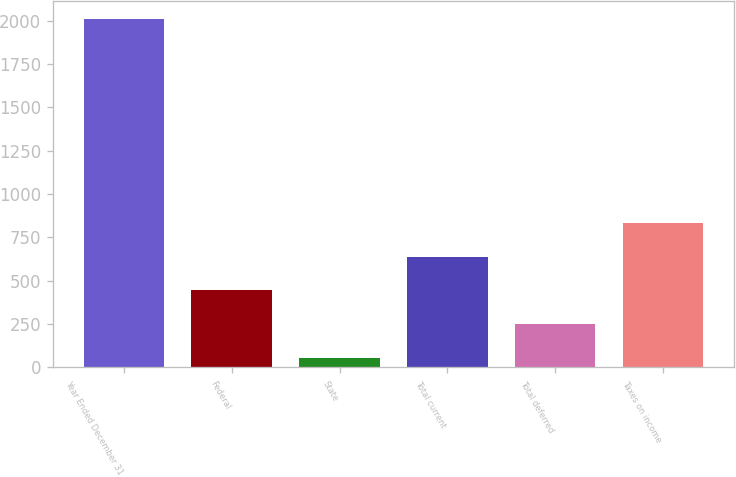<chart> <loc_0><loc_0><loc_500><loc_500><bar_chart><fcel>Year Ended December 31<fcel>Federal<fcel>State<fcel>Total current<fcel>Total deferred<fcel>Taxes on income<nl><fcel>2011<fcel>443.8<fcel>52<fcel>639.7<fcel>247.9<fcel>835.6<nl></chart> 